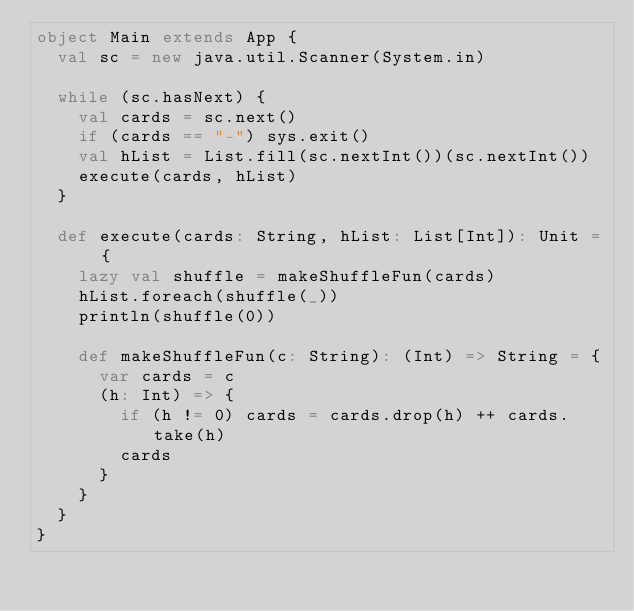<code> <loc_0><loc_0><loc_500><loc_500><_Scala_>object Main extends App {
  val sc = new java.util.Scanner(System.in)

  while (sc.hasNext) {
    val cards = sc.next()
    if (cards == "-") sys.exit()
    val hList = List.fill(sc.nextInt())(sc.nextInt())
    execute(cards, hList)
  }

  def execute(cards: String, hList: List[Int]): Unit = {
    lazy val shuffle = makeShuffleFun(cards)
    hList.foreach(shuffle(_))
    println(shuffle(0))

    def makeShuffleFun(c: String): (Int) => String = {
      var cards = c
      (h: Int) => {
        if (h != 0) cards = cards.drop(h) ++ cards.take(h)
        cards
      }
    }
  }
}</code> 